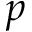Convert formula to latex. <formula><loc_0><loc_0><loc_500><loc_500>p</formula> 